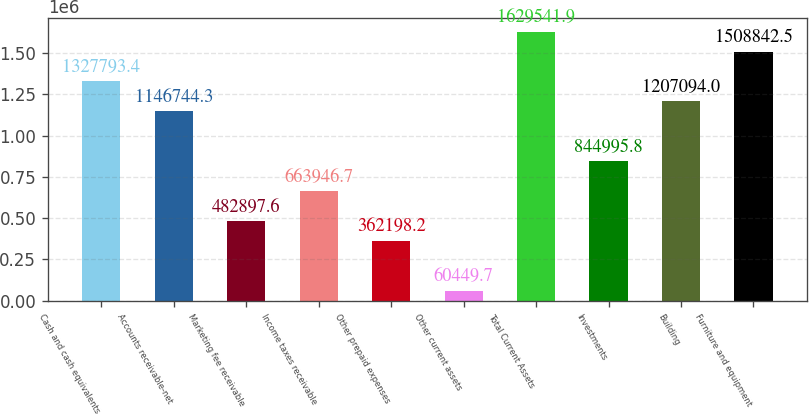Convert chart to OTSL. <chart><loc_0><loc_0><loc_500><loc_500><bar_chart><fcel>Cash and cash equivalents<fcel>Accounts receivable-net<fcel>Marketing fee receivable<fcel>Income taxes receivable<fcel>Other prepaid expenses<fcel>Other current assets<fcel>Total Current Assets<fcel>Investments<fcel>Building<fcel>Furniture and equipment<nl><fcel>1.32779e+06<fcel>1.14674e+06<fcel>482898<fcel>663947<fcel>362198<fcel>60449.7<fcel>1.62954e+06<fcel>844996<fcel>1.20709e+06<fcel>1.50884e+06<nl></chart> 